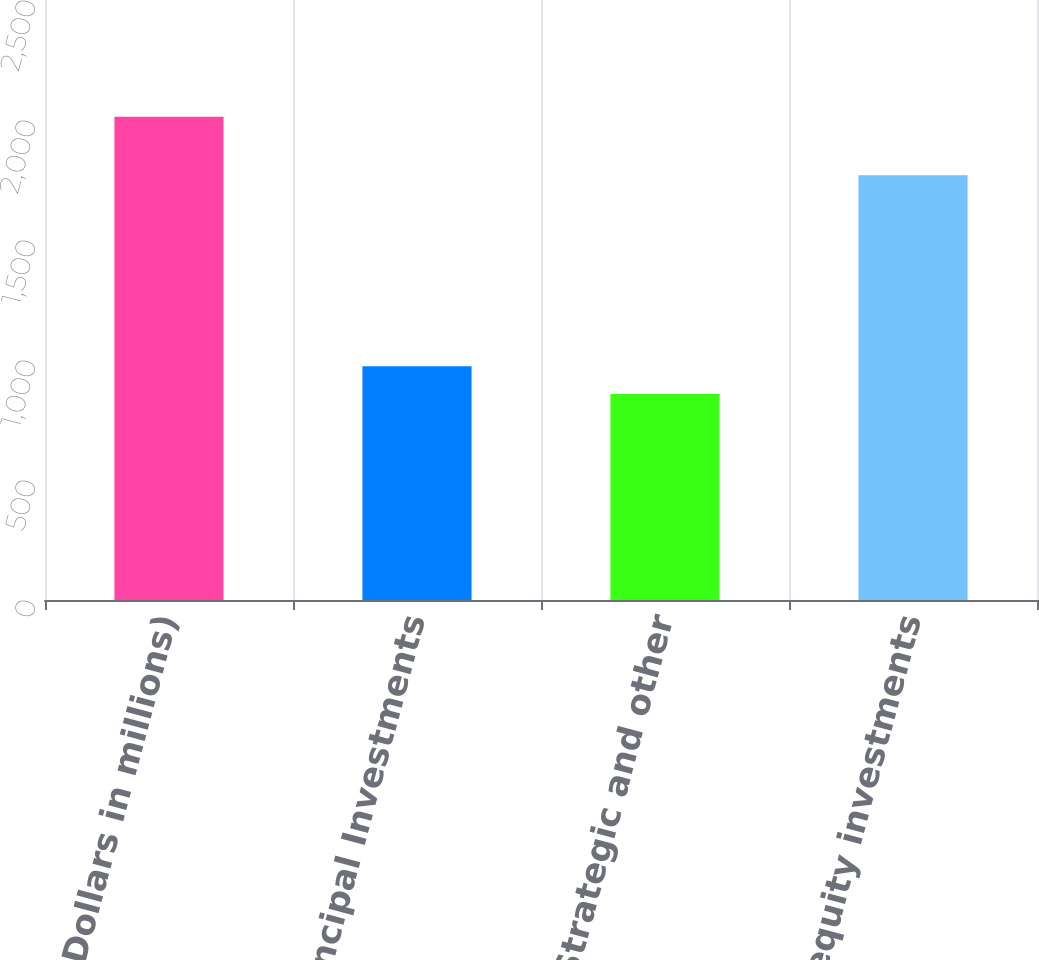Convert chart to OTSL. <chart><loc_0><loc_0><loc_500><loc_500><bar_chart><fcel>(Dollars in millions)<fcel>Global Principal Investments<fcel>Strategic and other<fcel>Total equity investments<nl><fcel>2014<fcel>973.6<fcel>858<fcel>1770<nl></chart> 